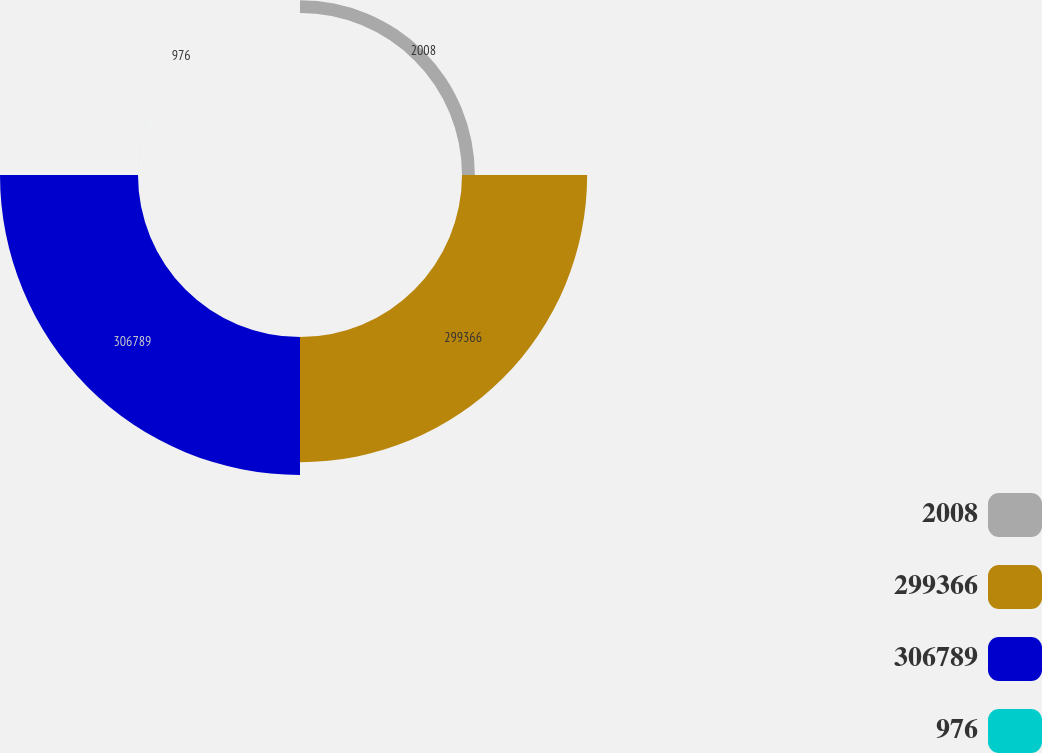<chart> <loc_0><loc_0><loc_500><loc_500><pie_chart><fcel>2008<fcel>299366<fcel>306789<fcel>976<nl><fcel>4.66%<fcel>45.34%<fcel>49.99%<fcel>0.01%<nl></chart> 